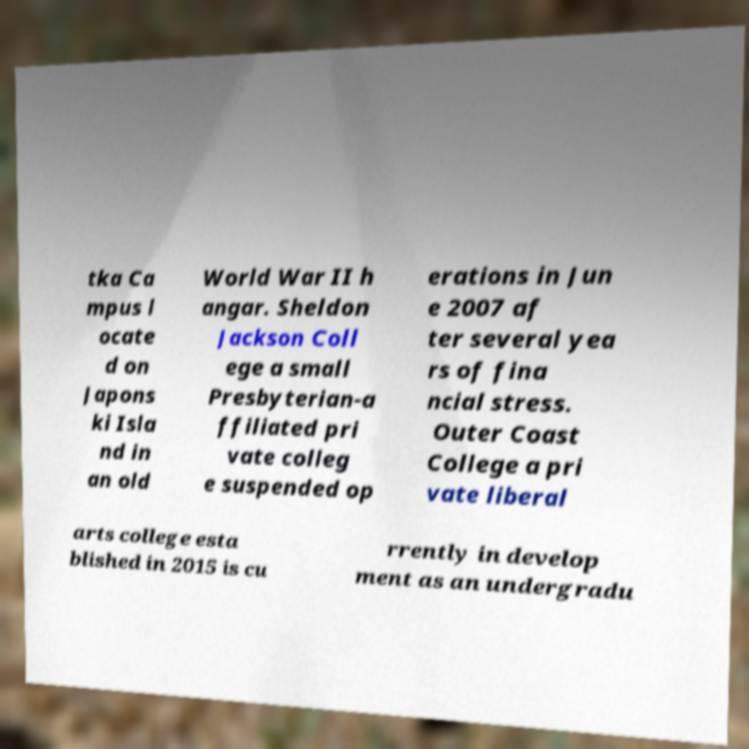I need the written content from this picture converted into text. Can you do that? tka Ca mpus l ocate d on Japons ki Isla nd in an old World War II h angar. Sheldon Jackson Coll ege a small Presbyterian-a ffiliated pri vate colleg e suspended op erations in Jun e 2007 af ter several yea rs of fina ncial stress. Outer Coast College a pri vate liberal arts college esta blished in 2015 is cu rrently in develop ment as an undergradu 